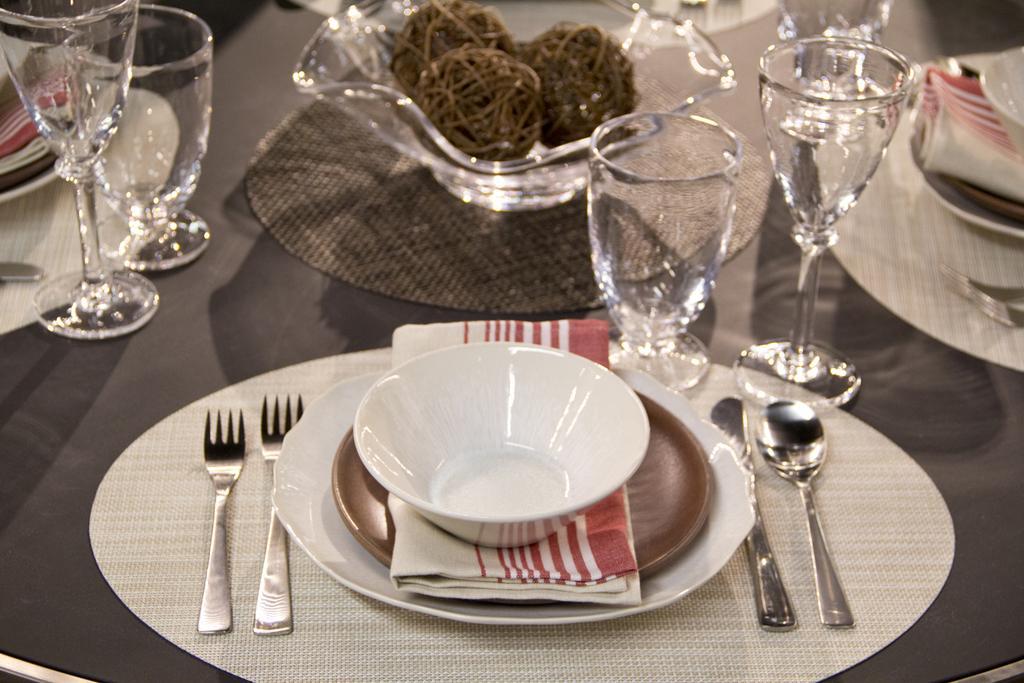Describe this image in one or two sentences. In this picture there is a table , in that table there is a table mat, 2 forks,a saucer, a napkin, a plate ,a bowl, 1 knife , 1 spoon in the table and at the right side of the spoon there is one table mat , 2 glasses and at the left side of the forks there are 2 glasses and at the background there is a glass bowl which consists of 3 wooden rounds. 